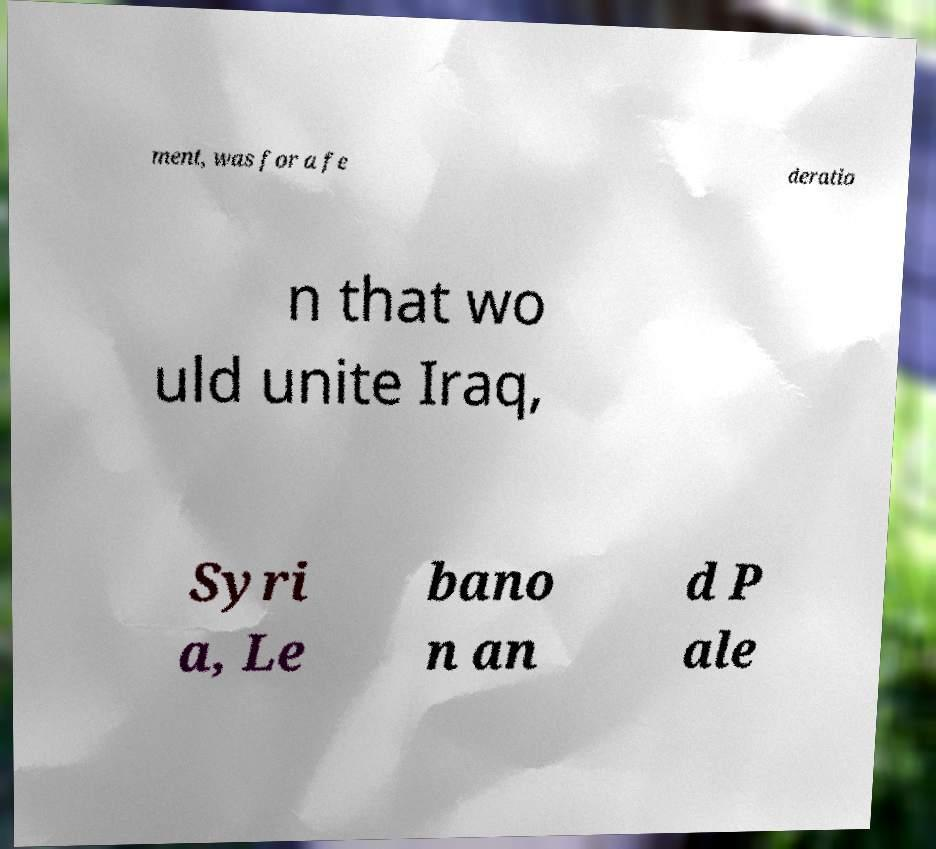Can you read and provide the text displayed in the image?This photo seems to have some interesting text. Can you extract and type it out for me? ment, was for a fe deratio n that wo uld unite Iraq, Syri a, Le bano n an d P ale 